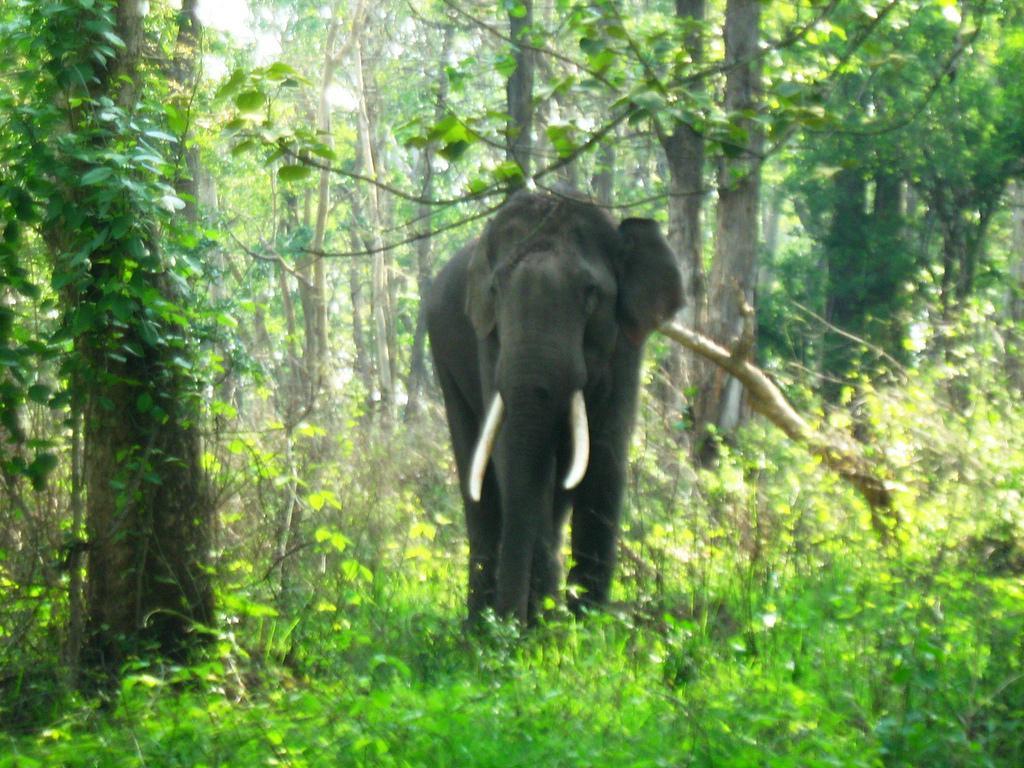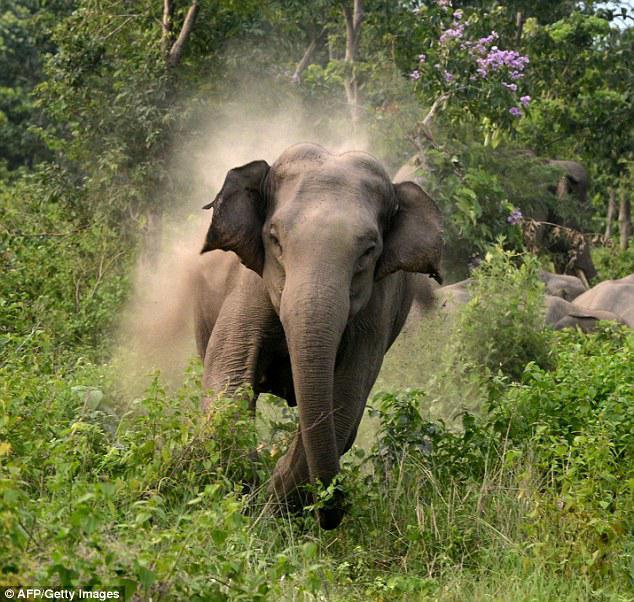The first image is the image on the left, the second image is the image on the right. Examine the images to the left and right. Is the description "Two elephants are in the grassy wilderness." accurate? Answer yes or no. Yes. The first image is the image on the left, the second image is the image on the right. Analyze the images presented: Is the assertion "An image shows a camera-facing elephant with tusks and trunk pointed downward." valid? Answer yes or no. Yes. 